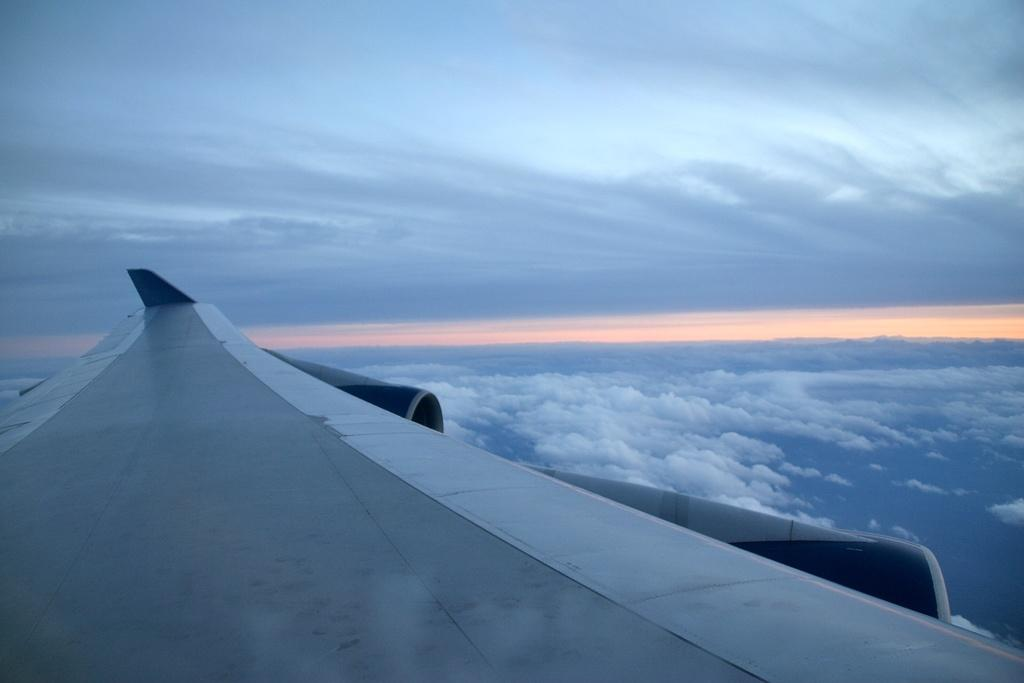What is the main subject of the picture? The main subject of the picture is an aeroplane wing. How would you describe the sky in the picture? The sky is blue and cloudy in the picture. Can you tell me what type of advertisement is displayed on the aeroplane wing in the image? There is no advertisement present on the aeroplane wing in the image. Is there a park visible in the background of the image? The image only shows an aeroplane wing and the sky, so there is no park visible in the background. 